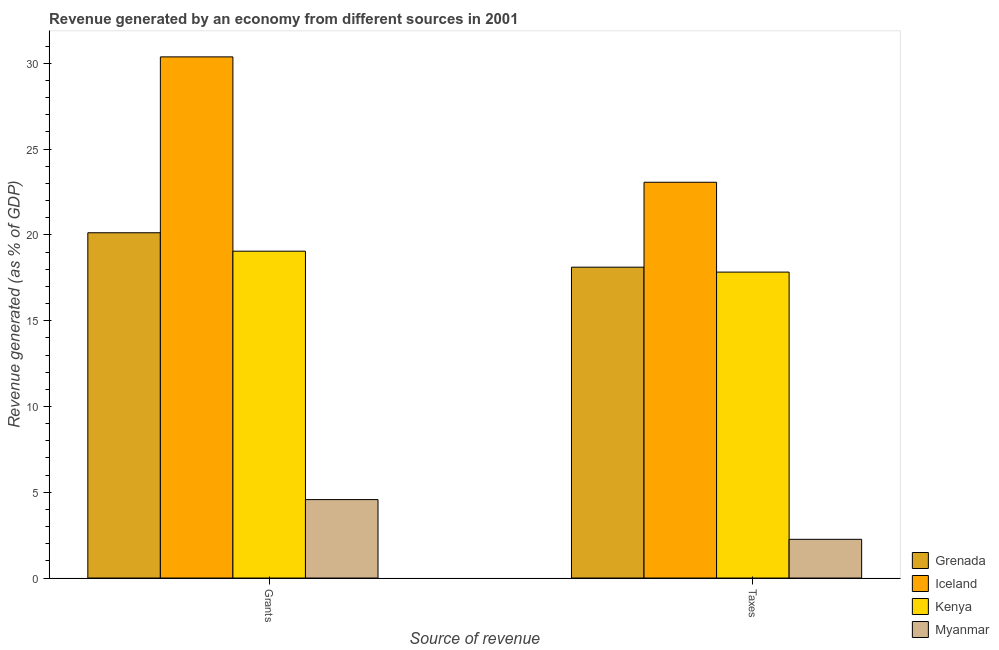How many groups of bars are there?
Your response must be concise. 2. Are the number of bars per tick equal to the number of legend labels?
Your response must be concise. Yes. Are the number of bars on each tick of the X-axis equal?
Your answer should be compact. Yes. How many bars are there on the 1st tick from the left?
Offer a very short reply. 4. How many bars are there on the 1st tick from the right?
Provide a short and direct response. 4. What is the label of the 1st group of bars from the left?
Provide a succinct answer. Grants. What is the revenue generated by taxes in Iceland?
Ensure brevity in your answer.  23.07. Across all countries, what is the maximum revenue generated by grants?
Ensure brevity in your answer.  30.38. Across all countries, what is the minimum revenue generated by taxes?
Provide a succinct answer. 2.26. In which country was the revenue generated by taxes maximum?
Your answer should be very brief. Iceland. In which country was the revenue generated by grants minimum?
Provide a short and direct response. Myanmar. What is the total revenue generated by taxes in the graph?
Provide a short and direct response. 61.28. What is the difference between the revenue generated by grants in Kenya and that in Myanmar?
Offer a terse response. 14.48. What is the difference between the revenue generated by taxes in Grenada and the revenue generated by grants in Myanmar?
Offer a very short reply. 13.55. What is the average revenue generated by taxes per country?
Your response must be concise. 15.32. What is the difference between the revenue generated by taxes and revenue generated by grants in Myanmar?
Your answer should be compact. -2.32. In how many countries, is the revenue generated by taxes greater than 3 %?
Your answer should be very brief. 3. What is the ratio of the revenue generated by grants in Myanmar to that in Iceland?
Your response must be concise. 0.15. Is the revenue generated by taxes in Grenada less than that in Iceland?
Give a very brief answer. Yes. What does the 4th bar from the left in Grants represents?
Your response must be concise. Myanmar. What does the 3rd bar from the right in Taxes represents?
Offer a terse response. Iceland. How many bars are there?
Make the answer very short. 8. Are all the bars in the graph horizontal?
Give a very brief answer. No. How many countries are there in the graph?
Keep it short and to the point. 4. Where does the legend appear in the graph?
Your response must be concise. Bottom right. How many legend labels are there?
Your answer should be compact. 4. What is the title of the graph?
Keep it short and to the point. Revenue generated by an economy from different sources in 2001. What is the label or title of the X-axis?
Make the answer very short. Source of revenue. What is the label or title of the Y-axis?
Your response must be concise. Revenue generated (as % of GDP). What is the Revenue generated (as % of GDP) of Grenada in Grants?
Your response must be concise. 20.13. What is the Revenue generated (as % of GDP) of Iceland in Grants?
Offer a terse response. 30.38. What is the Revenue generated (as % of GDP) in Kenya in Grants?
Your answer should be very brief. 19.05. What is the Revenue generated (as % of GDP) in Myanmar in Grants?
Your response must be concise. 4.57. What is the Revenue generated (as % of GDP) of Grenada in Taxes?
Give a very brief answer. 18.12. What is the Revenue generated (as % of GDP) of Iceland in Taxes?
Offer a very short reply. 23.07. What is the Revenue generated (as % of GDP) in Kenya in Taxes?
Keep it short and to the point. 17.83. What is the Revenue generated (as % of GDP) of Myanmar in Taxes?
Offer a terse response. 2.26. Across all Source of revenue, what is the maximum Revenue generated (as % of GDP) of Grenada?
Give a very brief answer. 20.13. Across all Source of revenue, what is the maximum Revenue generated (as % of GDP) of Iceland?
Offer a very short reply. 30.38. Across all Source of revenue, what is the maximum Revenue generated (as % of GDP) in Kenya?
Ensure brevity in your answer.  19.05. Across all Source of revenue, what is the maximum Revenue generated (as % of GDP) in Myanmar?
Your response must be concise. 4.57. Across all Source of revenue, what is the minimum Revenue generated (as % of GDP) in Grenada?
Your answer should be very brief. 18.12. Across all Source of revenue, what is the minimum Revenue generated (as % of GDP) in Iceland?
Offer a very short reply. 23.07. Across all Source of revenue, what is the minimum Revenue generated (as % of GDP) in Kenya?
Give a very brief answer. 17.83. Across all Source of revenue, what is the minimum Revenue generated (as % of GDP) of Myanmar?
Offer a very short reply. 2.26. What is the total Revenue generated (as % of GDP) in Grenada in the graph?
Make the answer very short. 38.24. What is the total Revenue generated (as % of GDP) of Iceland in the graph?
Keep it short and to the point. 53.44. What is the total Revenue generated (as % of GDP) in Kenya in the graph?
Keep it short and to the point. 36.88. What is the total Revenue generated (as % of GDP) of Myanmar in the graph?
Make the answer very short. 6.83. What is the difference between the Revenue generated (as % of GDP) in Grenada in Grants and that in Taxes?
Ensure brevity in your answer.  2.01. What is the difference between the Revenue generated (as % of GDP) of Iceland in Grants and that in Taxes?
Make the answer very short. 7.31. What is the difference between the Revenue generated (as % of GDP) in Kenya in Grants and that in Taxes?
Offer a terse response. 1.22. What is the difference between the Revenue generated (as % of GDP) of Myanmar in Grants and that in Taxes?
Provide a short and direct response. 2.32. What is the difference between the Revenue generated (as % of GDP) of Grenada in Grants and the Revenue generated (as % of GDP) of Iceland in Taxes?
Keep it short and to the point. -2.94. What is the difference between the Revenue generated (as % of GDP) of Grenada in Grants and the Revenue generated (as % of GDP) of Kenya in Taxes?
Your answer should be very brief. 2.29. What is the difference between the Revenue generated (as % of GDP) in Grenada in Grants and the Revenue generated (as % of GDP) in Myanmar in Taxes?
Your answer should be compact. 17.87. What is the difference between the Revenue generated (as % of GDP) in Iceland in Grants and the Revenue generated (as % of GDP) in Kenya in Taxes?
Keep it short and to the point. 12.54. What is the difference between the Revenue generated (as % of GDP) in Iceland in Grants and the Revenue generated (as % of GDP) in Myanmar in Taxes?
Ensure brevity in your answer.  28.12. What is the difference between the Revenue generated (as % of GDP) in Kenya in Grants and the Revenue generated (as % of GDP) in Myanmar in Taxes?
Offer a terse response. 16.79. What is the average Revenue generated (as % of GDP) of Grenada per Source of revenue?
Keep it short and to the point. 19.12. What is the average Revenue generated (as % of GDP) of Iceland per Source of revenue?
Provide a short and direct response. 26.72. What is the average Revenue generated (as % of GDP) of Kenya per Source of revenue?
Provide a succinct answer. 18.44. What is the average Revenue generated (as % of GDP) in Myanmar per Source of revenue?
Your answer should be compact. 3.41. What is the difference between the Revenue generated (as % of GDP) in Grenada and Revenue generated (as % of GDP) in Iceland in Grants?
Make the answer very short. -10.25. What is the difference between the Revenue generated (as % of GDP) of Grenada and Revenue generated (as % of GDP) of Kenya in Grants?
Give a very brief answer. 1.07. What is the difference between the Revenue generated (as % of GDP) of Grenada and Revenue generated (as % of GDP) of Myanmar in Grants?
Provide a succinct answer. 15.55. What is the difference between the Revenue generated (as % of GDP) in Iceland and Revenue generated (as % of GDP) in Kenya in Grants?
Give a very brief answer. 11.32. What is the difference between the Revenue generated (as % of GDP) of Iceland and Revenue generated (as % of GDP) of Myanmar in Grants?
Make the answer very short. 25.8. What is the difference between the Revenue generated (as % of GDP) in Kenya and Revenue generated (as % of GDP) in Myanmar in Grants?
Keep it short and to the point. 14.48. What is the difference between the Revenue generated (as % of GDP) in Grenada and Revenue generated (as % of GDP) in Iceland in Taxes?
Your answer should be very brief. -4.95. What is the difference between the Revenue generated (as % of GDP) in Grenada and Revenue generated (as % of GDP) in Kenya in Taxes?
Your response must be concise. 0.29. What is the difference between the Revenue generated (as % of GDP) in Grenada and Revenue generated (as % of GDP) in Myanmar in Taxes?
Keep it short and to the point. 15.86. What is the difference between the Revenue generated (as % of GDP) in Iceland and Revenue generated (as % of GDP) in Kenya in Taxes?
Your response must be concise. 5.24. What is the difference between the Revenue generated (as % of GDP) in Iceland and Revenue generated (as % of GDP) in Myanmar in Taxes?
Offer a very short reply. 20.81. What is the difference between the Revenue generated (as % of GDP) of Kenya and Revenue generated (as % of GDP) of Myanmar in Taxes?
Your response must be concise. 15.57. What is the ratio of the Revenue generated (as % of GDP) of Grenada in Grants to that in Taxes?
Offer a terse response. 1.11. What is the ratio of the Revenue generated (as % of GDP) in Iceland in Grants to that in Taxes?
Offer a very short reply. 1.32. What is the ratio of the Revenue generated (as % of GDP) of Kenya in Grants to that in Taxes?
Offer a very short reply. 1.07. What is the ratio of the Revenue generated (as % of GDP) in Myanmar in Grants to that in Taxes?
Your response must be concise. 2.03. What is the difference between the highest and the second highest Revenue generated (as % of GDP) of Grenada?
Your answer should be very brief. 2.01. What is the difference between the highest and the second highest Revenue generated (as % of GDP) of Iceland?
Offer a very short reply. 7.31. What is the difference between the highest and the second highest Revenue generated (as % of GDP) of Kenya?
Provide a short and direct response. 1.22. What is the difference between the highest and the second highest Revenue generated (as % of GDP) in Myanmar?
Your answer should be very brief. 2.32. What is the difference between the highest and the lowest Revenue generated (as % of GDP) in Grenada?
Keep it short and to the point. 2.01. What is the difference between the highest and the lowest Revenue generated (as % of GDP) in Iceland?
Your answer should be very brief. 7.31. What is the difference between the highest and the lowest Revenue generated (as % of GDP) of Kenya?
Make the answer very short. 1.22. What is the difference between the highest and the lowest Revenue generated (as % of GDP) of Myanmar?
Ensure brevity in your answer.  2.32. 